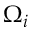Convert formula to latex. <formula><loc_0><loc_0><loc_500><loc_500>\Omega _ { i }</formula> 